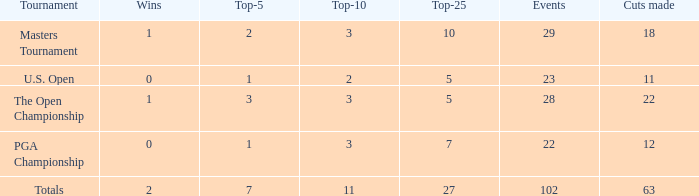What quantity of top 10s corresponds to 3 top 5s and under 22 cuts made? None. 